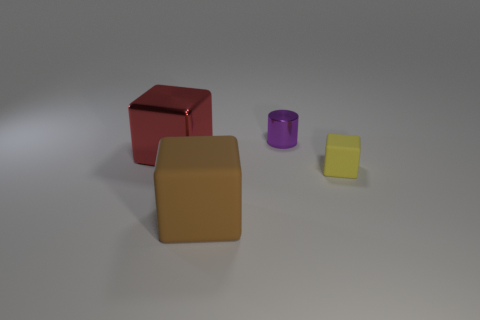Add 2 green cylinders. How many objects exist? 6 Subtract all big red blocks. How many blocks are left? 2 Subtract all red cubes. How many cubes are left? 2 Subtract 2 blocks. How many blocks are left? 1 Subtract all cylinders. How many objects are left? 3 Subtract all cyan cubes. How many cyan cylinders are left? 0 Subtract all big red metallic objects. Subtract all purple things. How many objects are left? 2 Add 3 big red shiny cubes. How many big red shiny cubes are left? 4 Add 4 big brown rubber blocks. How many big brown rubber blocks exist? 5 Subtract 0 purple balls. How many objects are left? 4 